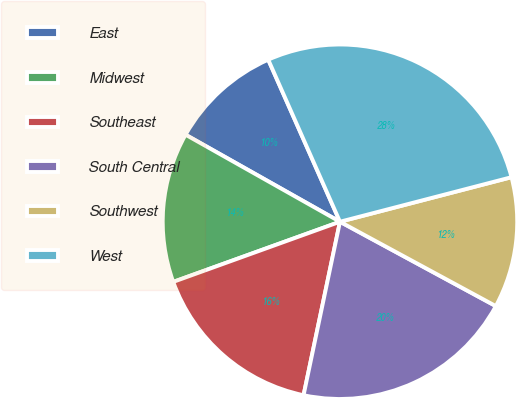Convert chart. <chart><loc_0><loc_0><loc_500><loc_500><pie_chart><fcel>East<fcel>Midwest<fcel>Southeast<fcel>South Central<fcel>Southwest<fcel>West<nl><fcel>10.2%<fcel>13.68%<fcel>16.2%<fcel>20.4%<fcel>11.94%<fcel>27.59%<nl></chart> 